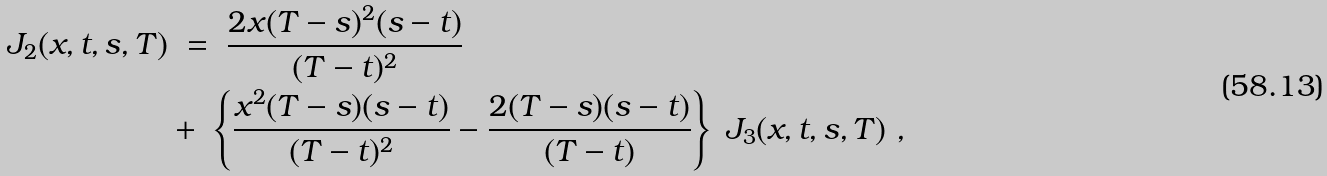Convert formula to latex. <formula><loc_0><loc_0><loc_500><loc_500>J _ { 2 } ( x , t , s , T ) & \ = \ \frac { 2 x ( T - s ) ^ { 2 } ( s - t ) } { ( T - t ) ^ { 2 } } \\ & + \ \left \{ \frac { x ^ { 2 } ( T - s ) ( s - t ) } { ( T - t ) ^ { 2 } } - \frac { 2 ( T - s ) ( s - t ) } { ( T - t ) } \right \} \ J _ { 3 } ( x , t , s , T ) \ ,</formula> 